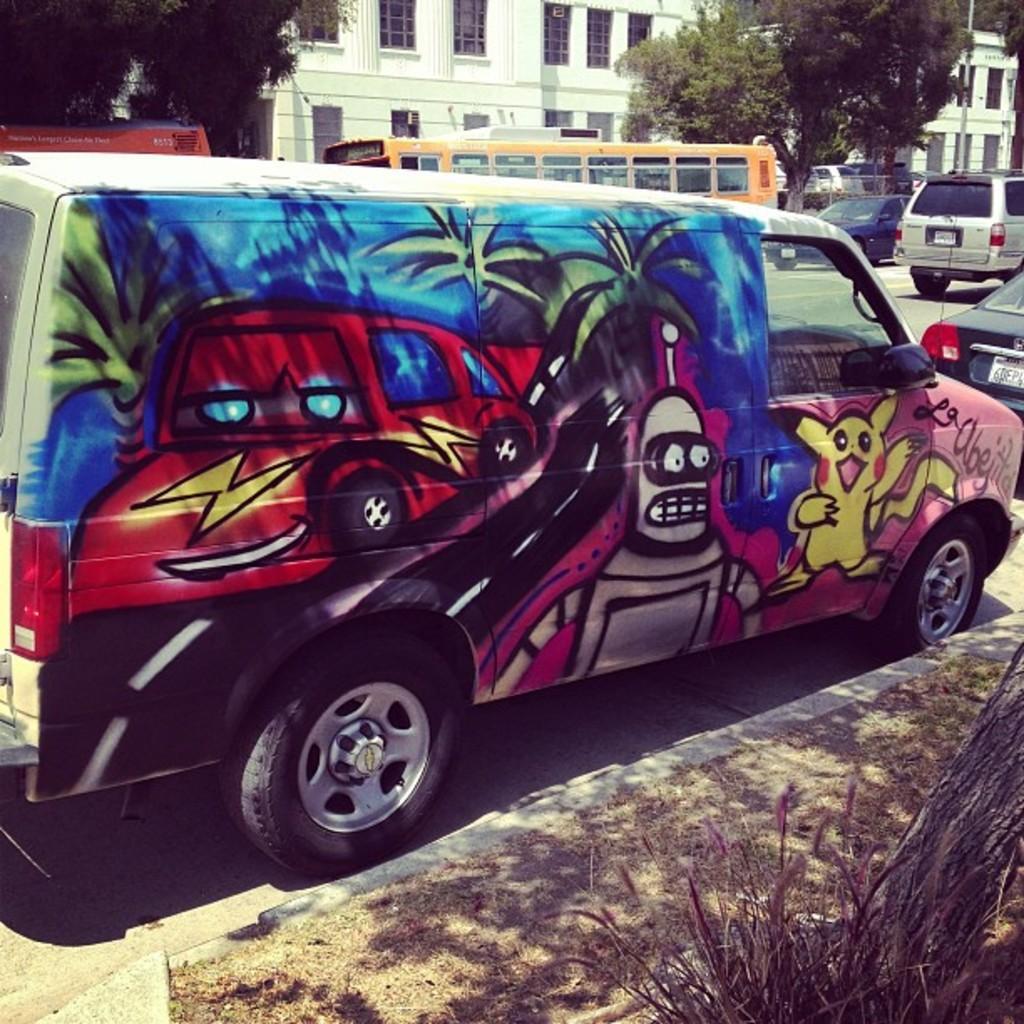In one or two sentences, can you explain what this image depicts? In this image I can see a van which is colorful on the road and I can see few other vehicles on the road, few trees and few buildings which are white in color in the background. 